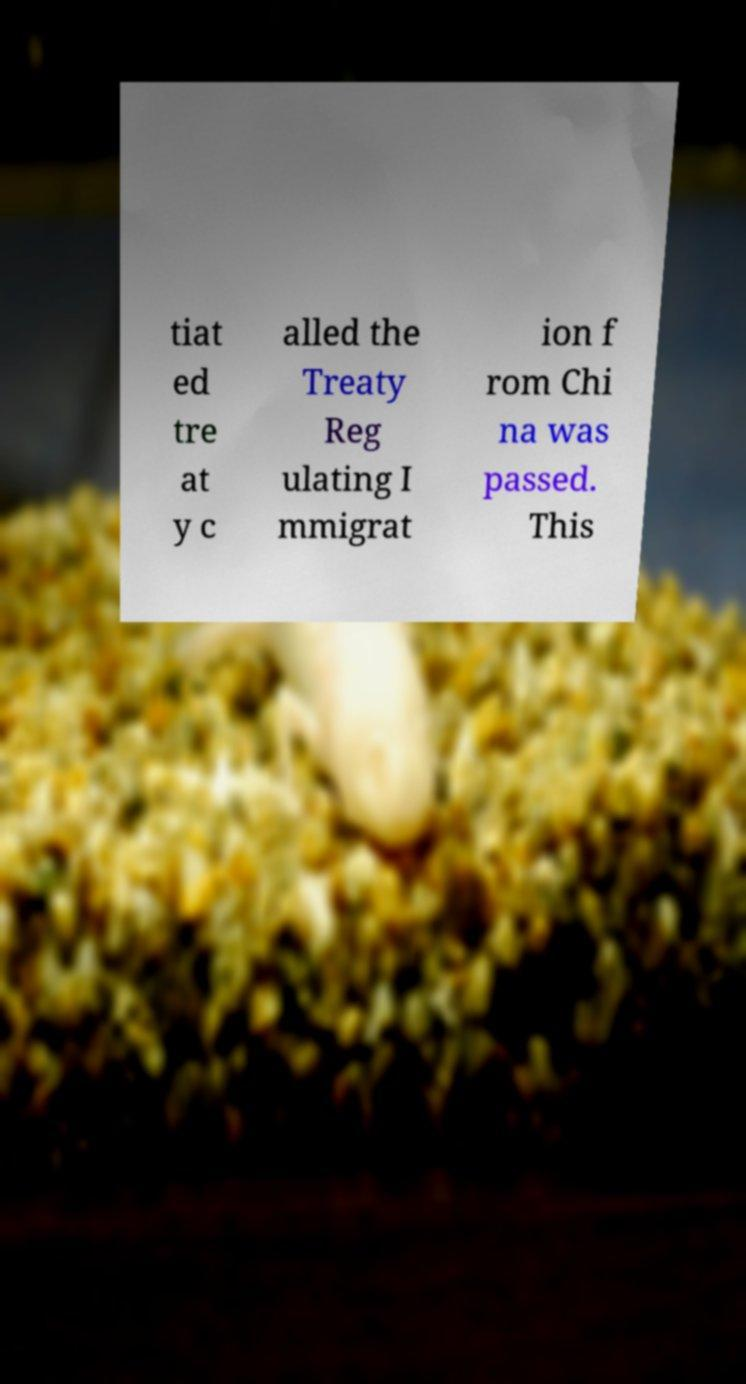Please read and relay the text visible in this image. What does it say? tiat ed tre at y c alled the Treaty Reg ulating I mmigrat ion f rom Chi na was passed. This 